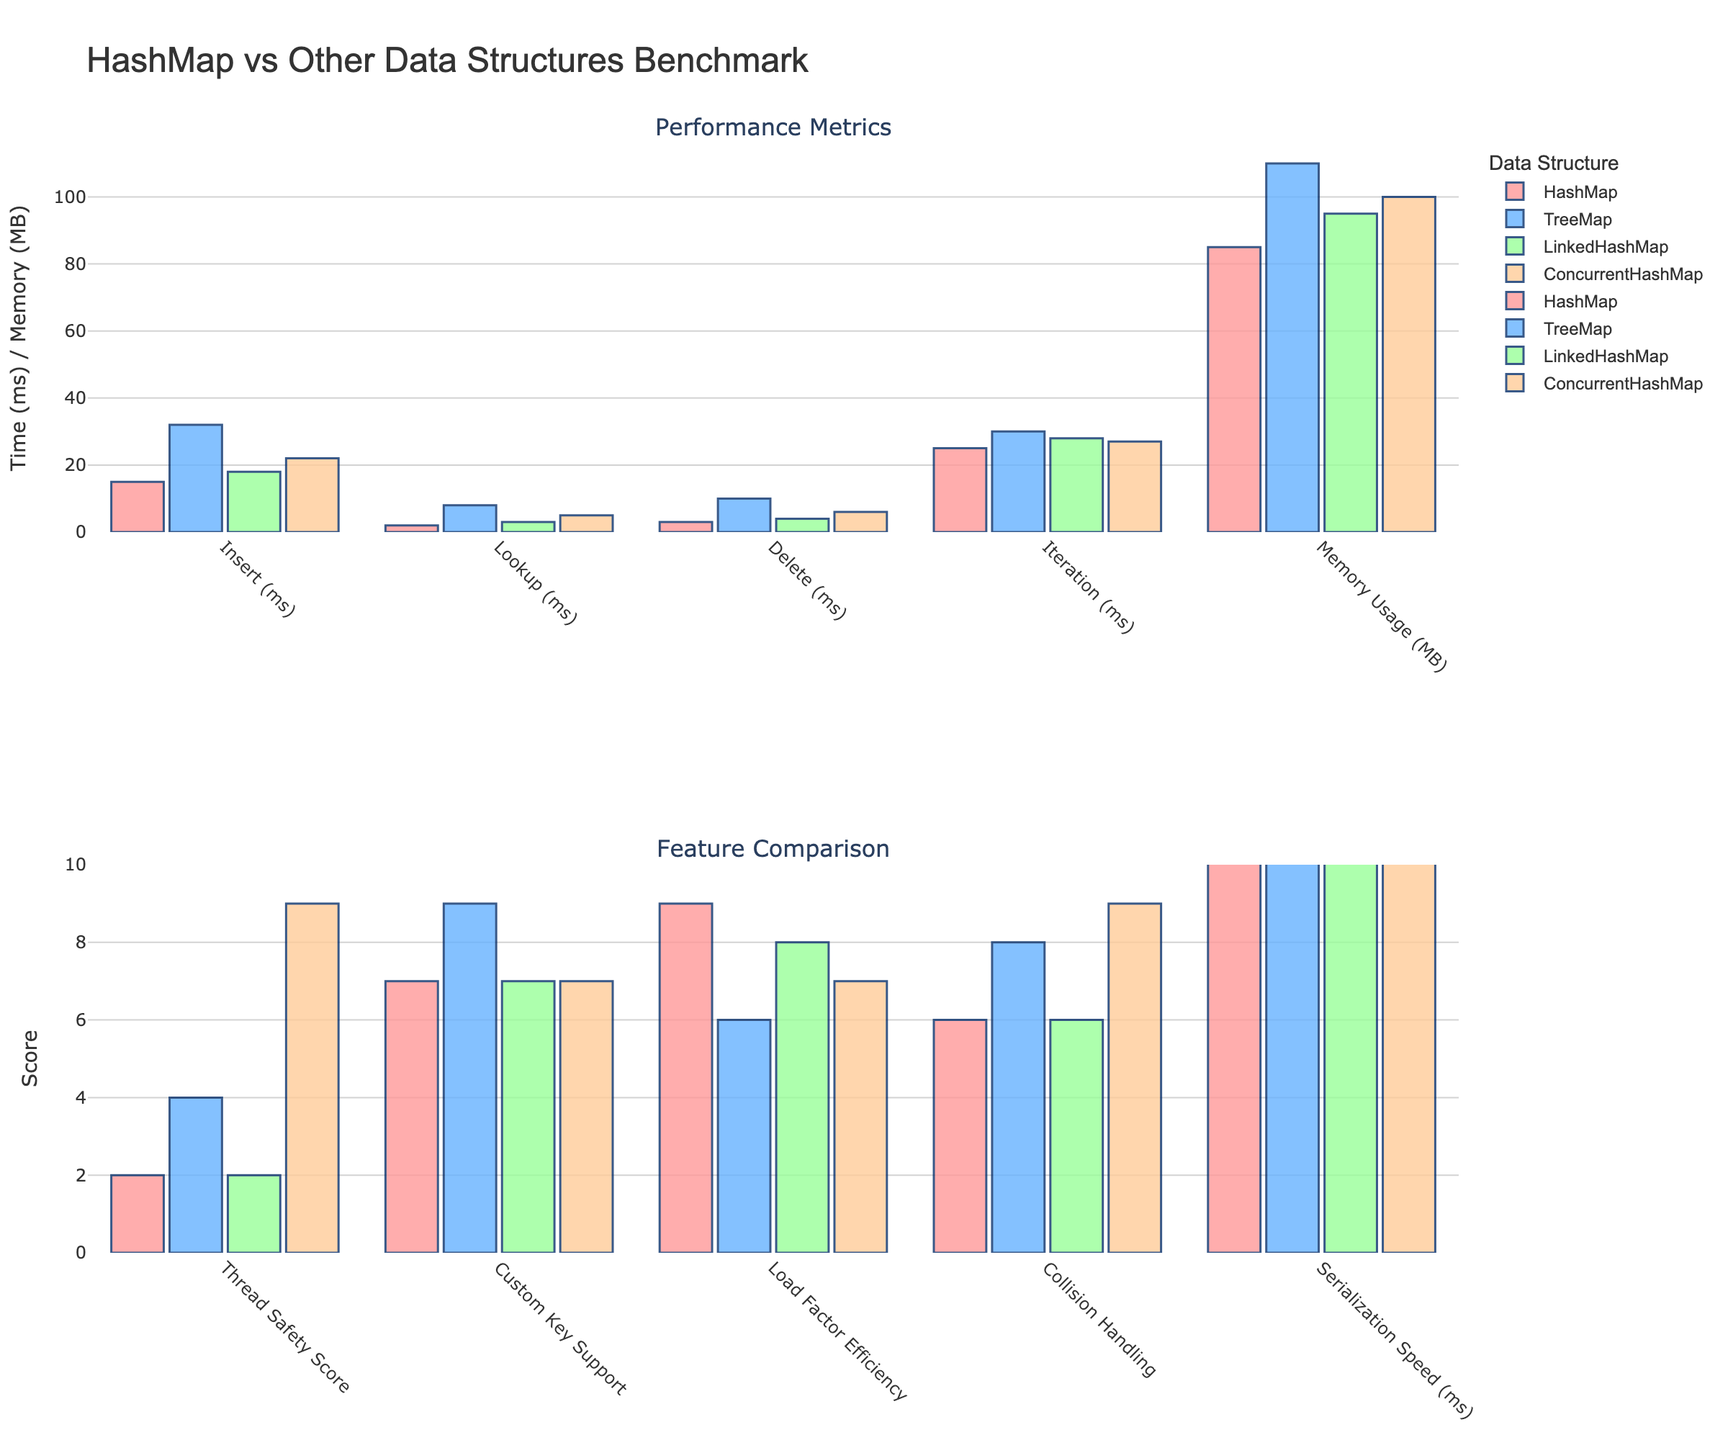What's the fastest data structure for the Insert operation? Look at the performance metrics section, particularly the bars corresponding to the Insert operation. The red bar (HashMap) is the shortest, indicating the fastest time.
Answer: HashMap Which data structure has the highest memory usage? In the performance metrics section, focus on the Memory Usage bars. The TreeMap (blue bar) is the tallest, indicating the highest memory usage.
Answer: TreeMap By how much does the Lookup time for TreeMap exceed that of ConcurrentHashMap? In the performance metrics section, compare the Lookup times. TreeMap's Lookup is 8 ms, and ConcurrentHashMap's is 5 ms. The difference is 8 - 5 = 3 ms.
Answer: 3 ms Which data structure provides the best thread safety? In the feature comparison section, look at the Thread Safety Score bars. The ConcurrentHashMap (yellow bar) is the highest, indicating the best thread safety score.
Answer: ConcurrentHashMap What's the average Load Factor Efficiency score across all data structures? In the feature comparison section, locate the Load Factor Efficiency scores: HashMap (9), TreeMap (6), LinkedHashMap (8), and ConcurrentHashMap (7). The average is (9 + 6 + 8 + 7) / 4 = 7.5.
Answer: 7.5 Between HashMap and LinkedHashMap, which has faster Serialization Speed and by how much? In the performance metrics section, compare the Serialization Speed bars for HashMap (12 ms) and LinkedHashMap (14 ms). The difference is 14 - 12 = 2 ms.
Answer: HashMap by 2 ms Which operation shows the smallest performance difference between TreeMap and ConcurrentHashMap? Compare all operation bars in the performance metrics section. For Delete, TreeMap takes 10 ms and ConcurrentHashMap takes 6 ms, a difference of 4 ms, which is the smallest gap between any pairs.
Answer: Delete In terms of Collision Handling, which two data structures perform equally well? In the feature comparison section, compare the Collision Handling scores. Both HashMap and LinkedHashMap have the same score of 6.
Answer: HashMap and LinkedHashMap What’s the total score for Custom Key Support and Thread Safety for TreeMap? In the feature comparison section, TreeMap scores 9 in Custom Key Support and 4 in Thread Safety. Their sum is 9 + 4 = 13.
Answer: 13 Which data structure has nearly identical performance for Iteration time compared to ConcurrentHashMap? In the performance metrics section, compare Iteration times. LinkedHashMap takes 28 ms, and ConcurrentHashMap takes 27 ms, which are nearly identical.
Answer: LinkedHashMap 